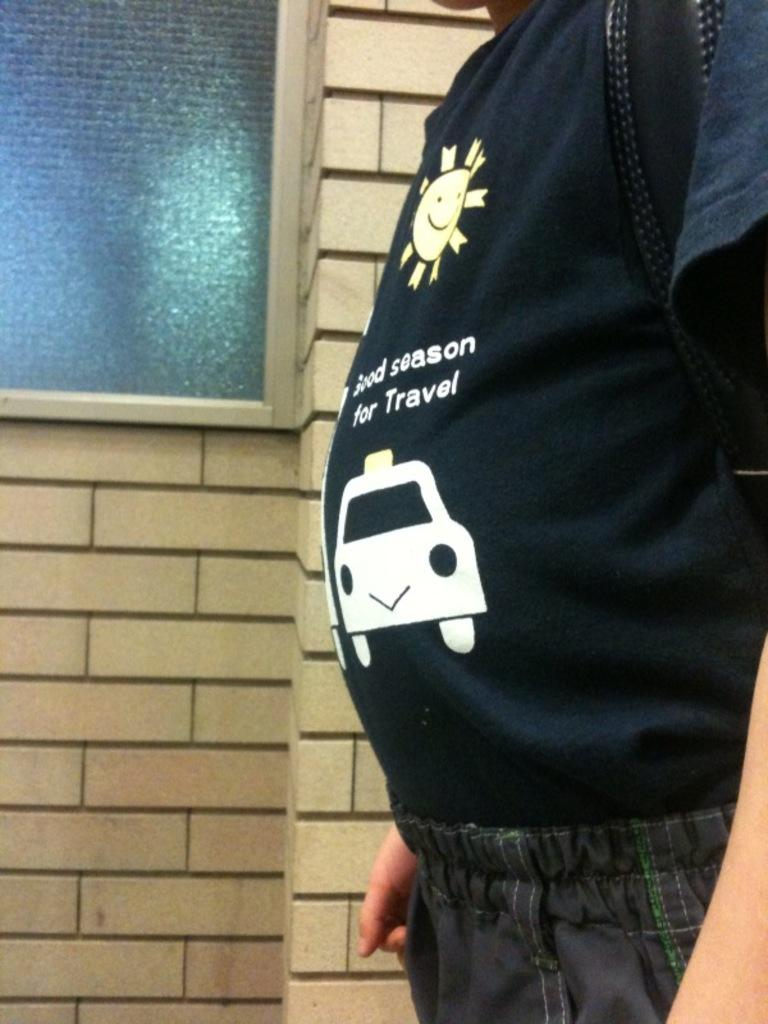What is the main subject of the image? There is a person standing in the image. What is the person wearing that is visible in the image? The person is wearing a bag. What can be seen in the background of the image? There is a wall with a glass window in the background of the image. What type of skin condition can be seen on the person's face in the image? There is no skin condition visible on the person's face in the image. Can you tell me how many gravestones are present in the cemetery in the image? There is no cemetery present in the image; it features a person standing with a bag and a wall with a glass window in the background. 